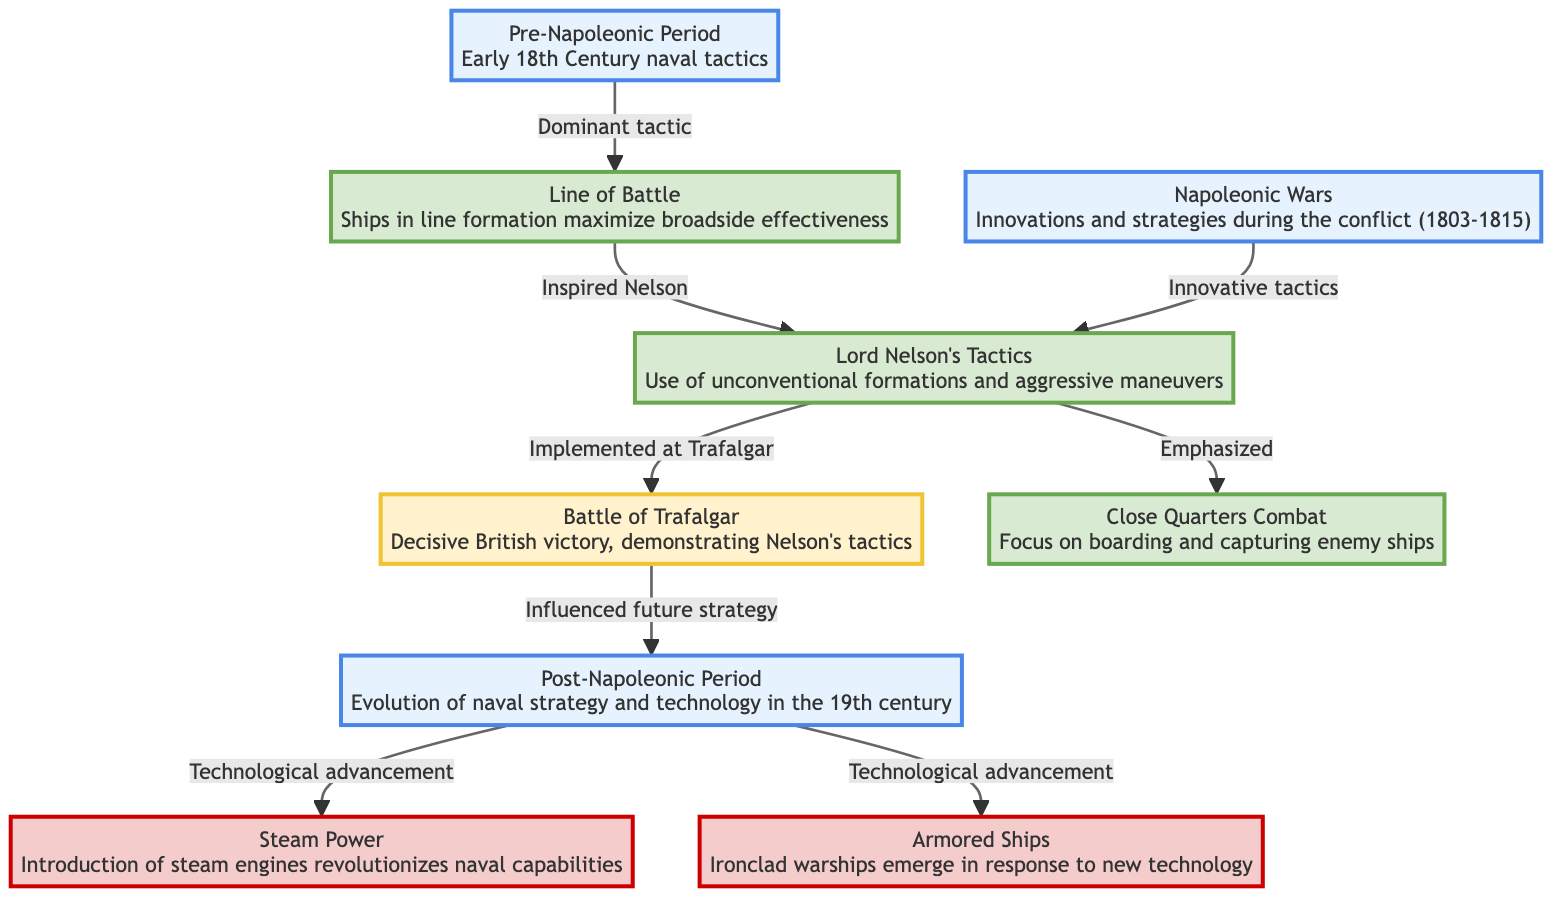What is the main tactic used in the pre-Napoleonic period? The diagram indicates that the dominant tactic during the pre-Napoleonic period is the "Line of Battle," aimed at maximizing broadside effectiveness.
Answer: Line of Battle Which battle is associated with Lord Nelson's tactics? The diagram highlights that Lord Nelson's unconventional tactics were directly implemented at the "Battle of Trafalgar," indicating a specific event where these tactics were showcased.
Answer: Battle of Trafalgar What technological advancement began in the post-Napoleonic period? The diagram states that the post-Napoleonic period saw the introduction of "Steam Power," marking a significant technological advancement in naval capabilities.
Answer: Steam Power How many main periods are illustrated in the diagram? The diagram consists of three main periods: Pre-Napoleonic Period, Napoleonic Wars, and Post-Napoleonic Period, making it easy to count and identify the distinct historical segments represented.
Answer: 3 Which tactic emphasized close quarters engagement? The diagram explicitly states that "Close Quarters Combat" was a key tactic that emphasized both boarding and capturing enemy ships during naval engagements.
Answer: Close Quarters Combat What innovation in naval warfare is associated with the Napoleonic Wars? The diagram denotes that the Napoleonic Wars were characterized by "Innovative tactics," suggesting new strategies and methods of warfare were developed during this period.
Answer: Innovative tactics Which node connects the Battle of Trafalgar to future naval strategy? According to the diagram, the "Battle of Trafalgar" links to the future strategy node, indicating it "Influenced future strategy," thus showing how past events shape subsequent naval doctrines.
Answer: Influenced future strategy What emerged in the post-Napoleonic period in response to new technology? The diagram specifies that "Armored Ships" emerged in the post-Napoleonic period as a direct response to advancements in naval technology, providing insight into the evolution of ship design.
Answer: Armored Ships Which tactic was inspired by the line of battle? The diagram illustrates that the "Line of Battle" inspired Lord Nelson's tactics, indicating a direct influence from traditional methods to his more innovative approaches.
Answer: Lord Nelson's Tactics 